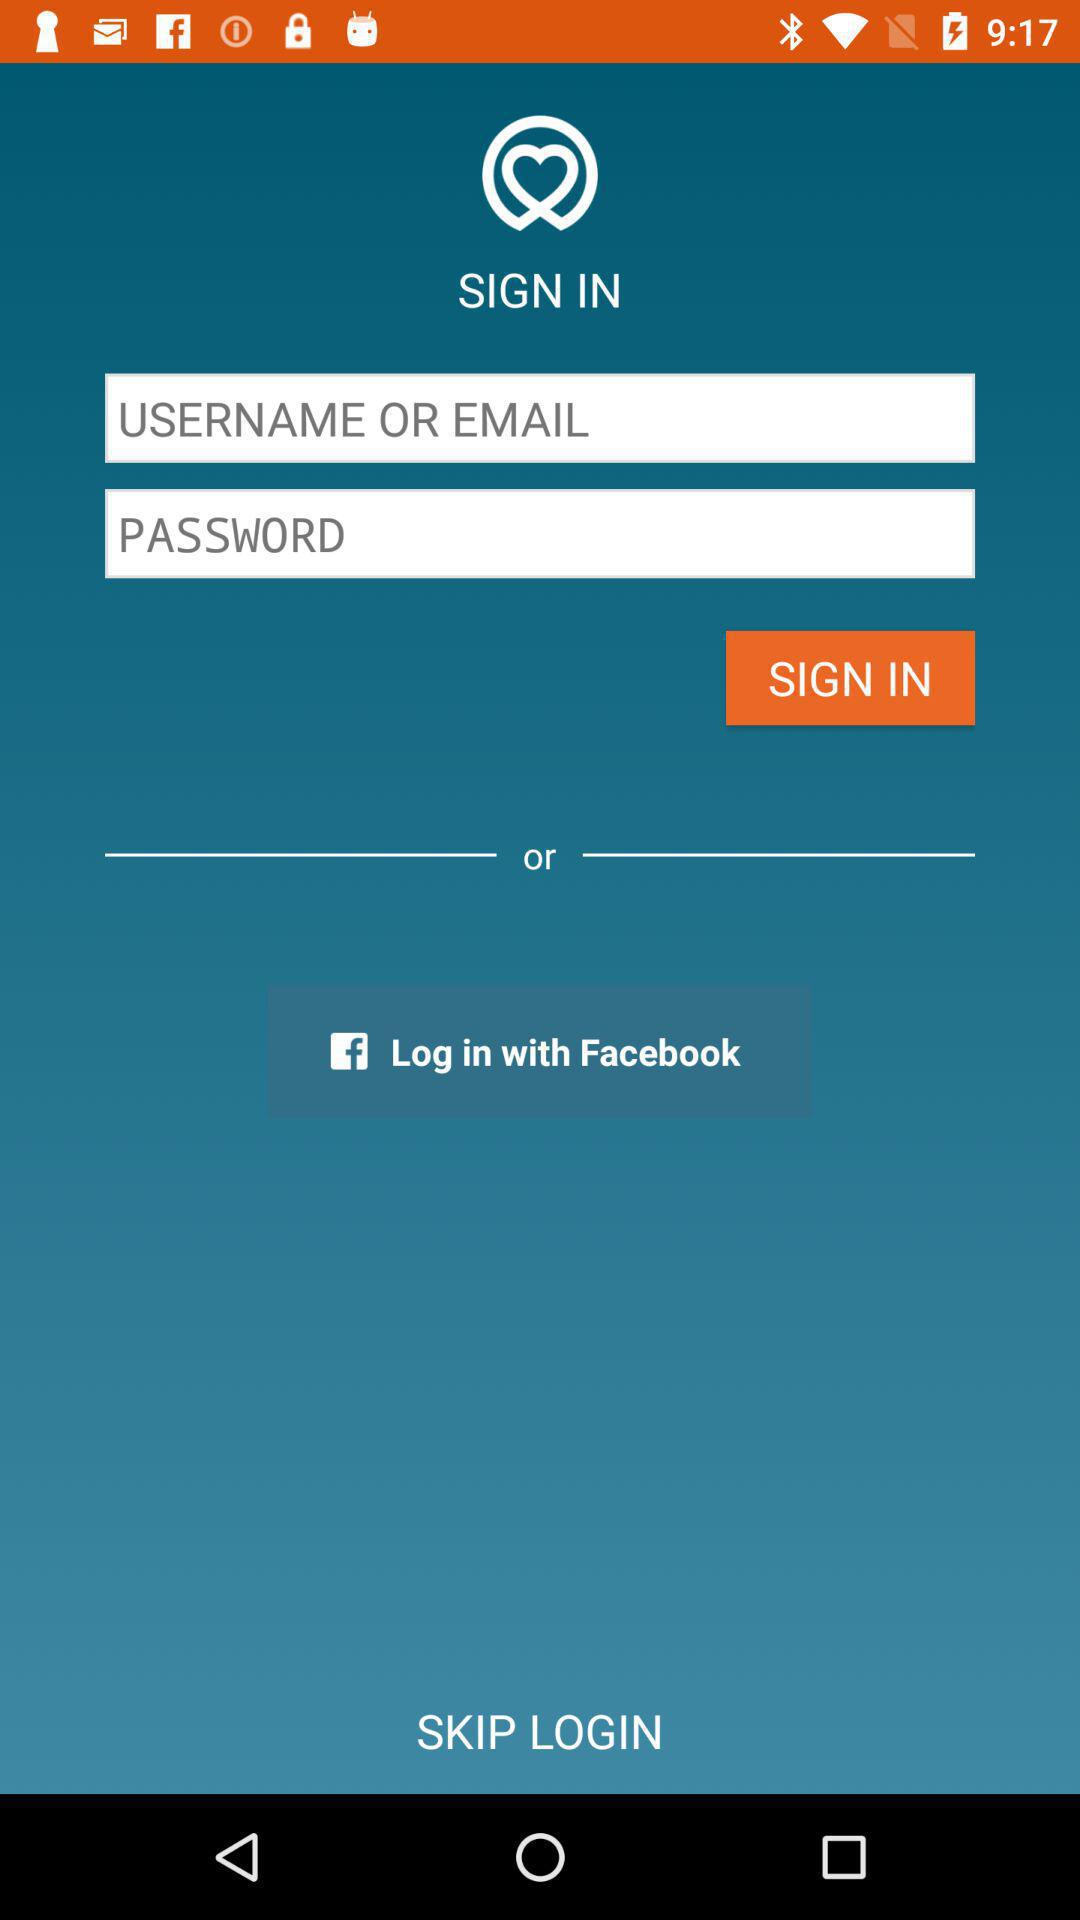What are the requirements to get a sign-in? The requirements are "USERNAME OR EMAIL" and "PASSWORD". 